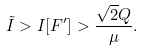Convert formula to latex. <formula><loc_0><loc_0><loc_500><loc_500>\tilde { I } > I [ F ^ { \prime } ] > \frac { \sqrt { 2 } Q } { \mu } .</formula> 